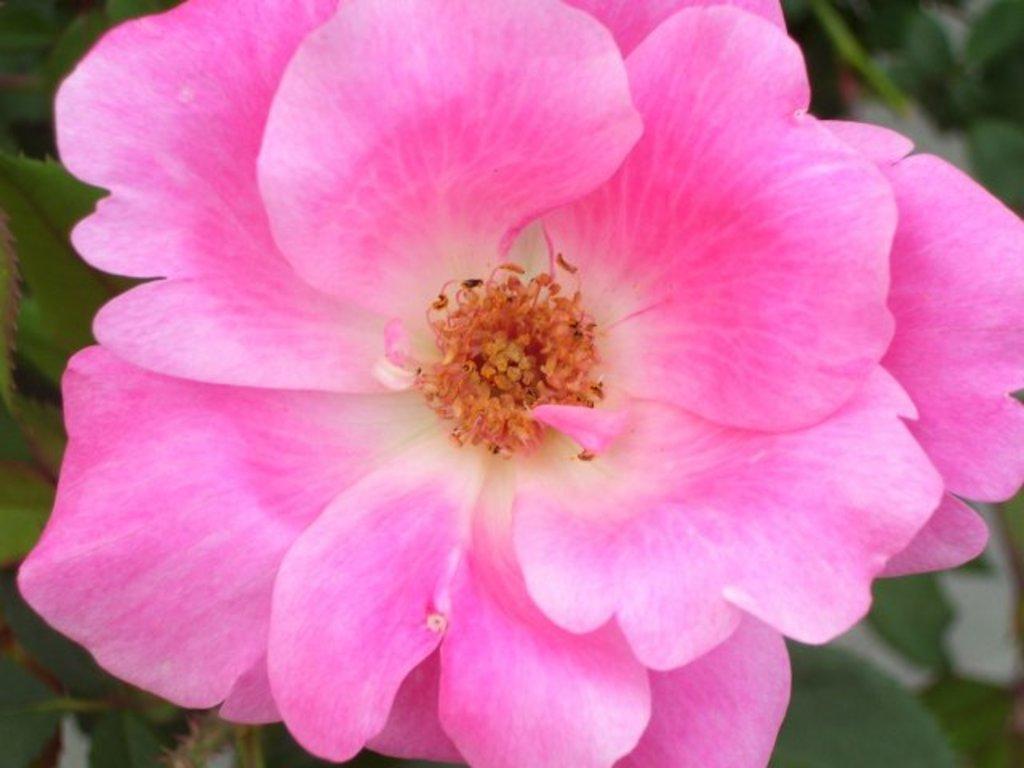Please provide a concise description of this image. In this image there is a pink color flower, the background is blurry. 